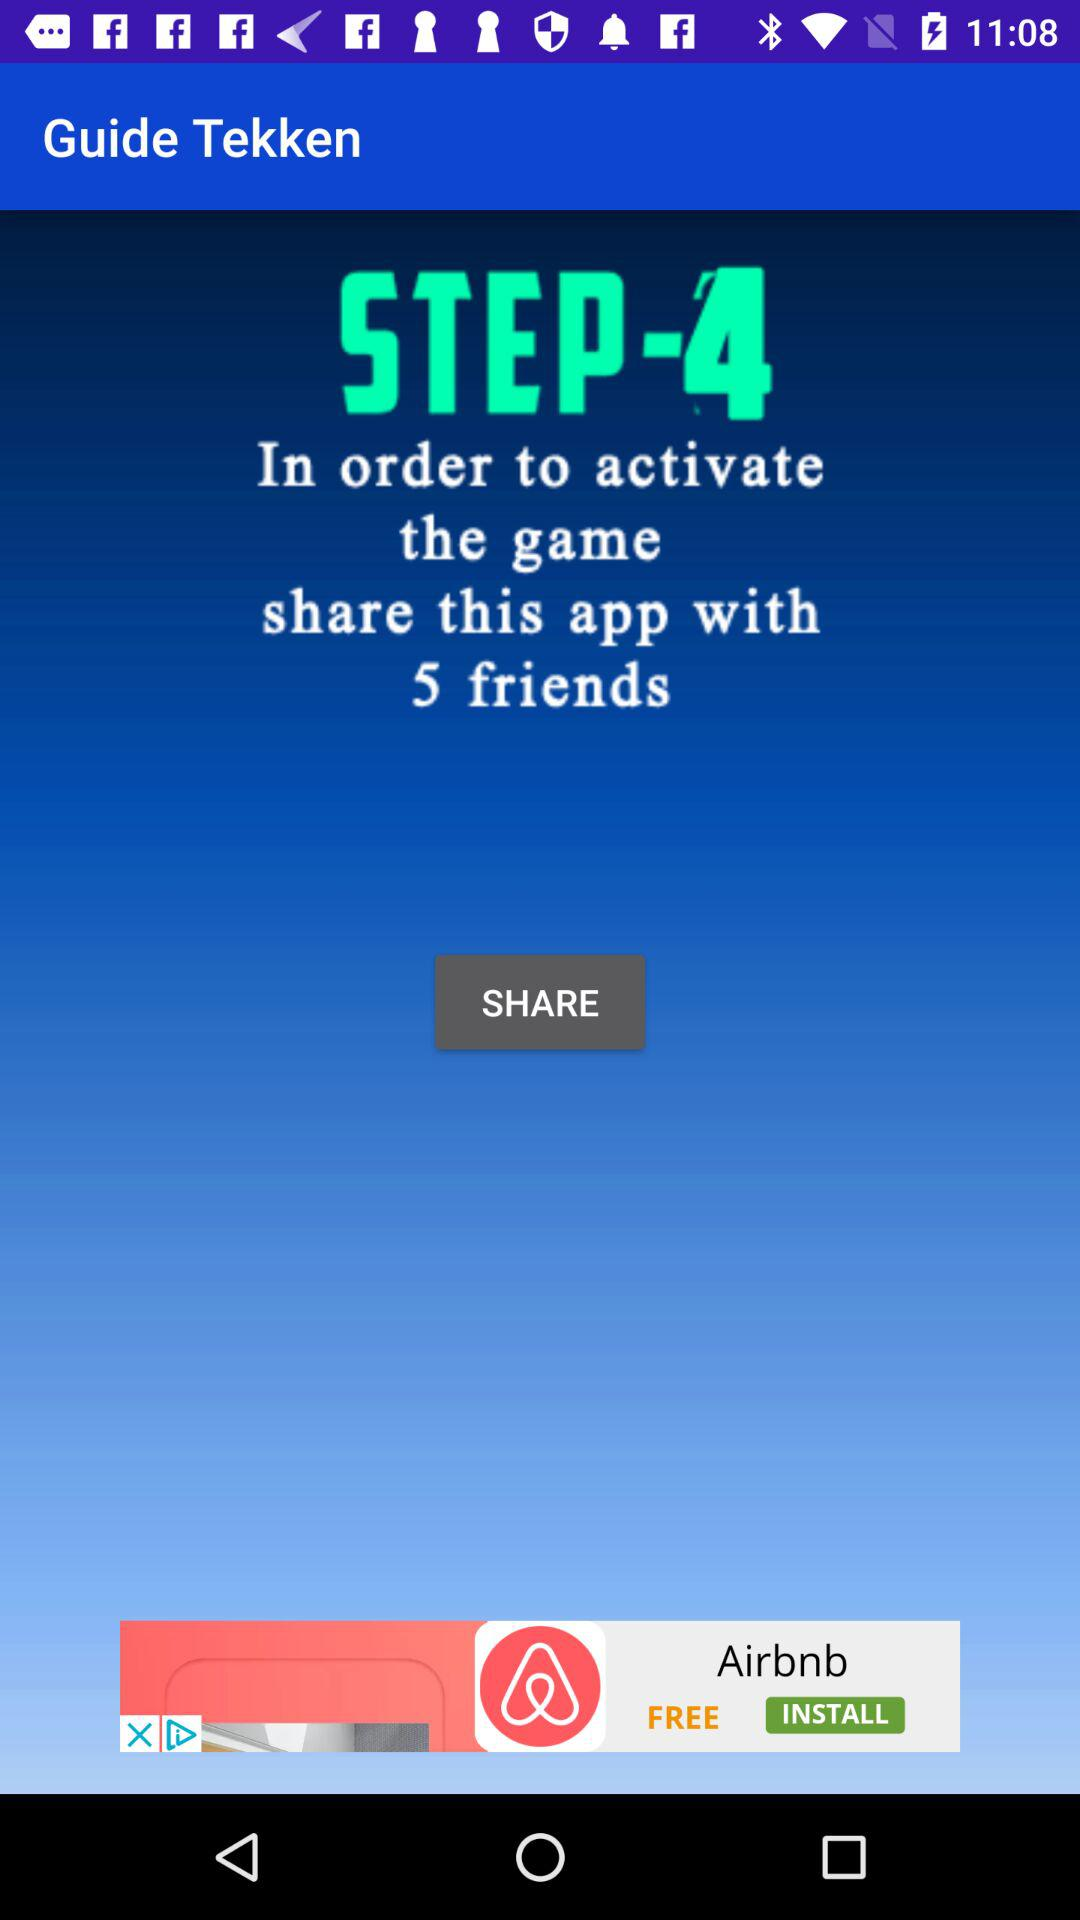How many more friends do I need to share the app with to activate the game?
Answer the question using a single word or phrase. 5 